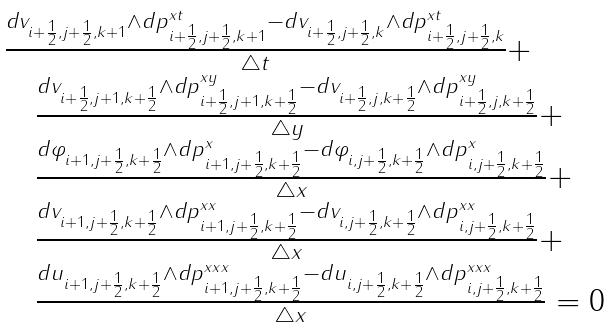<formula> <loc_0><loc_0><loc_500><loc_500>\begin{array} { l } \frac { d v _ { i + \frac { 1 } { 2 } , j + \frac { 1 } { 2 } , k + 1 } \wedge d p ^ { x t } _ { i + \frac { 1 } { 2 } , j + \frac { 1 } { 2 } , k + 1 } - d v _ { i + \frac { 1 } { 2 } , j + \frac { 1 } { 2 } , k } \wedge d p ^ { x t } _ { i + \frac { 1 } { 2 } , j + \frac { 1 } { 2 } , k } } { \bigtriangleup t } + \\ \quad \frac { d v _ { i + \frac { 1 } { 2 } , j + 1 , k + \frac { 1 } { 2 } } \wedge d p ^ { x y } _ { i + \frac { 1 } { 2 } , j + 1 , k + \frac { 1 } { 2 } } - d v _ { i + \frac { 1 } { 2 } , j , k + \frac { 1 } { 2 } } \wedge d p ^ { x y } _ { i + \frac { 1 } { 2 } , j , k + \frac { 1 } { 2 } } } { \bigtriangleup y } + \\ \quad \frac { d \varphi _ { i + 1 , j + \frac { 1 } { 2 } , k + \frac { 1 } { 2 } } \wedge d p ^ { x } _ { i + 1 , j + \frac { 1 } { 2 } , k + \frac { 1 } { 2 } } - d \varphi _ { i , j + \frac { 1 } { 2 } , k + \frac { 1 } { 2 } } \wedge d p ^ { x } _ { i , j + \frac { 1 } { 2 } , k + \frac { 1 } { 2 } } } { \bigtriangleup x } + \\ \quad \frac { d v _ { i + 1 , j + \frac { 1 } { 2 } , k + \frac { 1 } { 2 } } \wedge d p ^ { x x } _ { i + 1 , j + \frac { 1 } { 2 } , k + \frac { 1 } { 2 } } - d v _ { i , j + \frac { 1 } { 2 } , k + \frac { 1 } { 2 } } \wedge d p ^ { x x } _ { i , j + \frac { 1 } { 2 } , k + \frac { 1 } { 2 } } } { \bigtriangleup x } + \\ \quad \frac { d u _ { i + 1 , j + \frac { 1 } { 2 } , k + \frac { 1 } { 2 } } \wedge d p ^ { x x x } _ { i + 1 , j + \frac { 1 } { 2 } , k + \frac { 1 } { 2 } } - d u _ { i , j + \frac { 1 } { 2 } , k + \frac { 1 } { 2 } } \wedge d p ^ { x x x } _ { i , j + \frac { 1 } { 2 } , k + \frac { 1 } { 2 } } } { \bigtriangleup x } = 0 \end{array}</formula> 